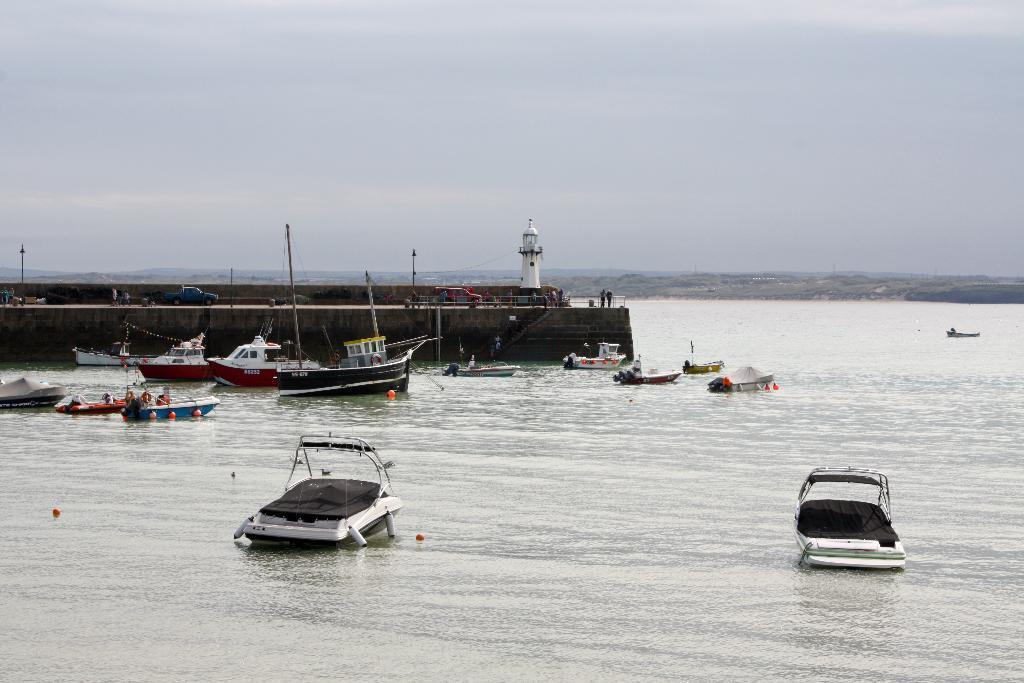What can be seen on the water surface in the foreground of the image? There are boats and ships on the water surface in the foreground. What structures are visible in the background of the image? There appears to be a bridge, a tower, and poles in the background. What type of vegetation is present in the background of the image? There are trees in the background. What is visible above the structures in the background? The sky is visible in the background. How many questions are floating in the water in the image? There are no questions present in the image; it features boats, ships, and various structures in the background. What type of powder can be seen covering the bridge in the image? There is no powder present on the bridge or any other structures in the image. 